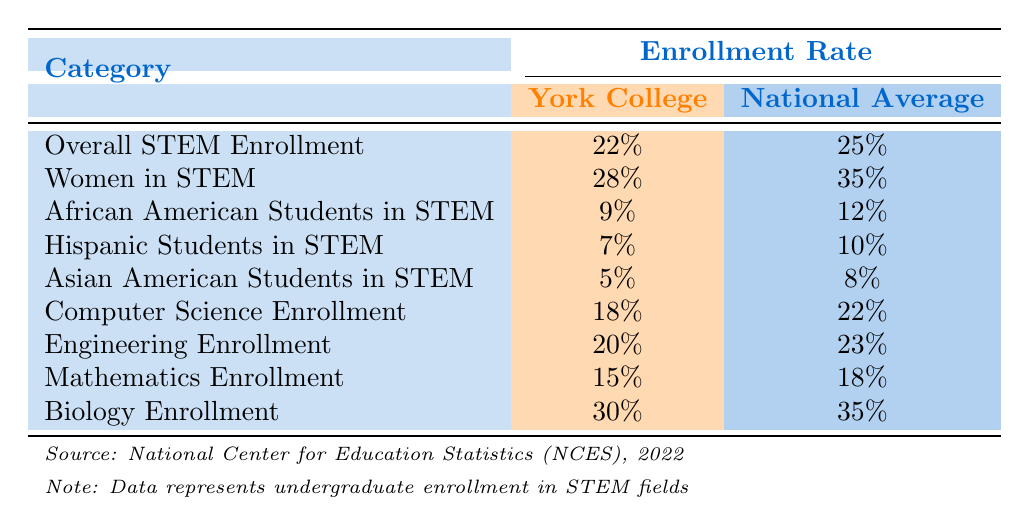What is the enrollment rate of women in STEM at York College? The table shows that the enrollment rate of women in STEM at York College is 28%.
Answer: 28% How does the enrollment rate of African American students in STEM at York College compare to the national average? The enrollment rate of African American students in STEM at York College is 9%, while the national average is 12%. Therefore, York College's rate is lower than the national average.
Answer: Lower What is the difference between the overall STEM enrollment rates at York College and the national average? York College's overall STEM enrollment rate is 22% and the national average is 25%. The difference is calculated as 25% - 22% = 3%.
Answer: 3% Is the enrollment rate for Computer Science at York College higher than the national average? The enrollment rate for Computer Science at York College is 18%, while the national average is 22%, which means York College's rate is lower.
Answer: No What percentage of Hispanic students are enrolled in STEM at York College compared to the national average? At York College, 7% of STEM students are Hispanic, whereas the national average is 10%. This indicates that the percentage at York College is lower than the national average.
Answer: Lower What is the average enrollment rate of Biology and Mathematics students at York College? The enrollment rates for Biology and Mathematics at York College are 30% and 15% respectively. The average is calculated as (30% + 15%)/2 = 22.5%.
Answer: 22.5% Is the percentage of Asian American students in STEM at York College greater than the percentage of Hispanic students? At York College, the percentage of Asian American students in STEM is 5%, while the percentage of Hispanic students is 7%. Therefore, the percentage of Asian American students is not greater.
Answer: No How much lower is the enrollment rate of women in STEM at York College compared to the national average? The enrollment rate of women in STEM at York College is 28%, while the national average is 35%. The difference is calculated as 35% - 28% = 7%.
Answer: 7% What is the combined percentage of African American and Hispanic students in STEM at the national average? The national average percentage for African American students is 12% and for Hispanic students is 10%. The combined percentage is calculated as 12% + 10% = 22%.
Answer: 22% 